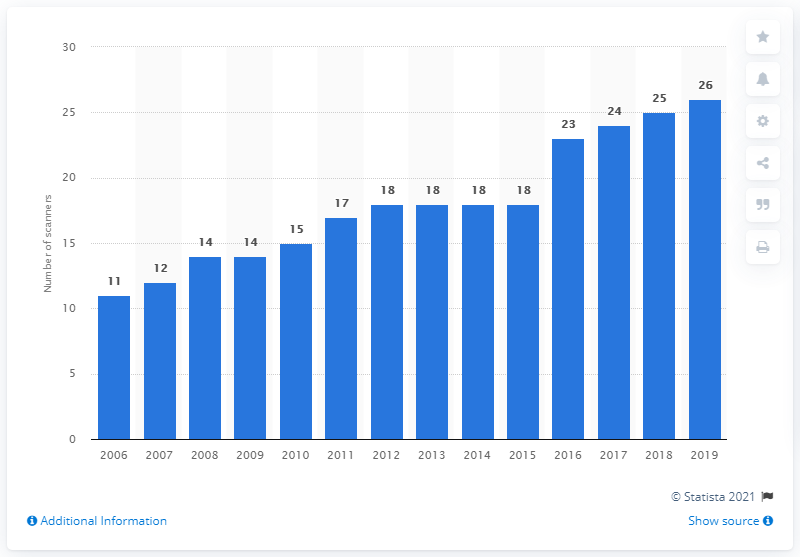Mention a couple of crucial points in this snapshot. There were 26 MRI scanners in Slovenia in 2019. 